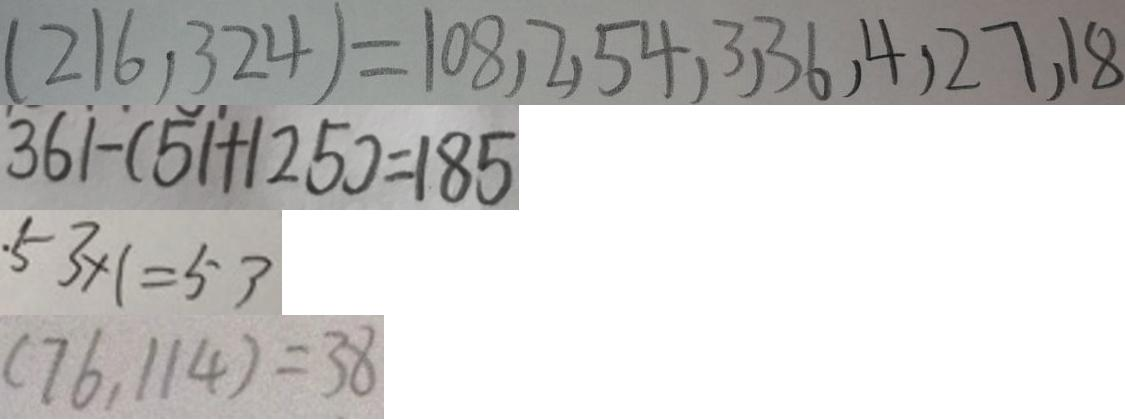Convert formula to latex. <formula><loc_0><loc_0><loc_500><loc_500>( 2 1 6 , 3 2 4 ) = 1 0 8 , 2 , 5 4 , 3 , 3 6 , 4 , 2 7 , 1 8 
 3 6 1 - ( 5 1 + 1 2 5 ) = 1 8 5 
 \cdot 5 3 \times 1 = 5 3 
 ( 7 6 , 1 1 4 ) = 3 8</formula> 